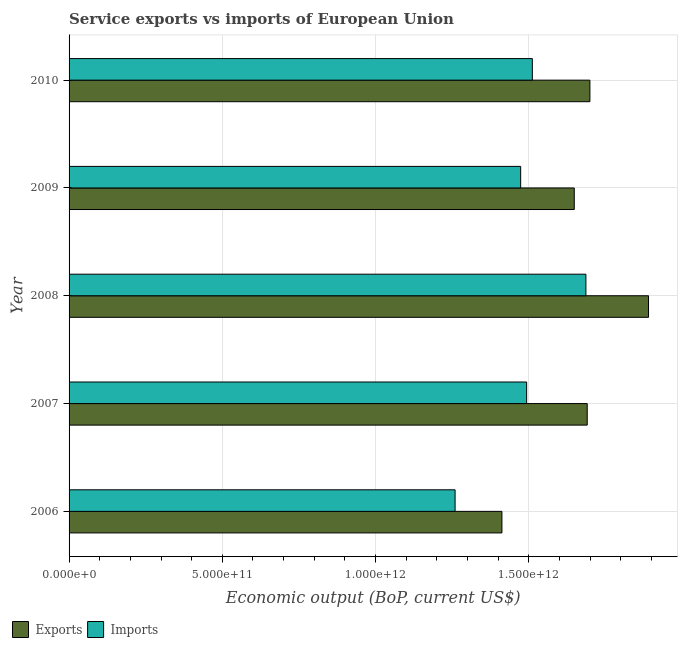How many different coloured bars are there?
Keep it short and to the point. 2. How many groups of bars are there?
Provide a succinct answer. 5. Are the number of bars per tick equal to the number of legend labels?
Your response must be concise. Yes. How many bars are there on the 3rd tick from the top?
Provide a short and direct response. 2. In how many cases, is the number of bars for a given year not equal to the number of legend labels?
Give a very brief answer. 0. What is the amount of service imports in 2008?
Your answer should be compact. 1.69e+12. Across all years, what is the maximum amount of service exports?
Offer a terse response. 1.89e+12. Across all years, what is the minimum amount of service imports?
Offer a very short reply. 1.26e+12. In which year was the amount of service imports maximum?
Make the answer very short. 2008. What is the total amount of service imports in the graph?
Ensure brevity in your answer.  7.42e+12. What is the difference between the amount of service exports in 2009 and that in 2010?
Offer a terse response. -5.11e+1. What is the difference between the amount of service imports in 2008 and the amount of service exports in 2007?
Keep it short and to the point. -4.27e+09. What is the average amount of service imports per year?
Your response must be concise. 1.48e+12. In the year 2007, what is the difference between the amount of service imports and amount of service exports?
Offer a very short reply. -1.98e+11. What is the ratio of the amount of service imports in 2007 to that in 2009?
Make the answer very short. 1.01. Is the difference between the amount of service exports in 2008 and 2009 greater than the difference between the amount of service imports in 2008 and 2009?
Offer a terse response. Yes. What is the difference between the highest and the second highest amount of service imports?
Your response must be concise. 1.75e+11. What is the difference between the highest and the lowest amount of service exports?
Offer a terse response. 4.78e+11. In how many years, is the amount of service imports greater than the average amount of service imports taken over all years?
Give a very brief answer. 3. What does the 1st bar from the top in 2010 represents?
Make the answer very short. Imports. What does the 1st bar from the bottom in 2010 represents?
Make the answer very short. Exports. What is the difference between two consecutive major ticks on the X-axis?
Your answer should be compact. 5.00e+11. Are the values on the major ticks of X-axis written in scientific E-notation?
Your answer should be very brief. Yes. Does the graph contain grids?
Offer a terse response. Yes. How many legend labels are there?
Offer a terse response. 2. How are the legend labels stacked?
Keep it short and to the point. Horizontal. What is the title of the graph?
Provide a succinct answer. Service exports vs imports of European Union. Does "Tetanus" appear as one of the legend labels in the graph?
Your answer should be very brief. No. What is the label or title of the X-axis?
Your response must be concise. Economic output (BoP, current US$). What is the Economic output (BoP, current US$) in Exports in 2006?
Offer a terse response. 1.41e+12. What is the Economic output (BoP, current US$) of Imports in 2006?
Give a very brief answer. 1.26e+12. What is the Economic output (BoP, current US$) of Exports in 2007?
Make the answer very short. 1.69e+12. What is the Economic output (BoP, current US$) of Imports in 2007?
Keep it short and to the point. 1.49e+12. What is the Economic output (BoP, current US$) in Exports in 2008?
Provide a short and direct response. 1.89e+12. What is the Economic output (BoP, current US$) in Imports in 2008?
Your answer should be very brief. 1.69e+12. What is the Economic output (BoP, current US$) of Exports in 2009?
Your response must be concise. 1.65e+12. What is the Economic output (BoP, current US$) in Imports in 2009?
Offer a very short reply. 1.47e+12. What is the Economic output (BoP, current US$) in Exports in 2010?
Provide a short and direct response. 1.70e+12. What is the Economic output (BoP, current US$) of Imports in 2010?
Provide a short and direct response. 1.51e+12. Across all years, what is the maximum Economic output (BoP, current US$) of Exports?
Provide a succinct answer. 1.89e+12. Across all years, what is the maximum Economic output (BoP, current US$) in Imports?
Ensure brevity in your answer.  1.69e+12. Across all years, what is the minimum Economic output (BoP, current US$) of Exports?
Offer a terse response. 1.41e+12. Across all years, what is the minimum Economic output (BoP, current US$) in Imports?
Provide a succinct answer. 1.26e+12. What is the total Economic output (BoP, current US$) of Exports in the graph?
Offer a very short reply. 8.34e+12. What is the total Economic output (BoP, current US$) of Imports in the graph?
Offer a very short reply. 7.42e+12. What is the difference between the Economic output (BoP, current US$) in Exports in 2006 and that in 2007?
Give a very brief answer. -2.78e+11. What is the difference between the Economic output (BoP, current US$) of Imports in 2006 and that in 2007?
Your answer should be very brief. -2.33e+11. What is the difference between the Economic output (BoP, current US$) in Exports in 2006 and that in 2008?
Ensure brevity in your answer.  -4.78e+11. What is the difference between the Economic output (BoP, current US$) in Imports in 2006 and that in 2008?
Your answer should be compact. -4.27e+11. What is the difference between the Economic output (BoP, current US$) in Exports in 2006 and that in 2009?
Offer a terse response. -2.36e+11. What is the difference between the Economic output (BoP, current US$) in Imports in 2006 and that in 2009?
Offer a very short reply. -2.14e+11. What is the difference between the Economic output (BoP, current US$) of Exports in 2006 and that in 2010?
Give a very brief answer. -2.87e+11. What is the difference between the Economic output (BoP, current US$) of Imports in 2006 and that in 2010?
Your response must be concise. -2.52e+11. What is the difference between the Economic output (BoP, current US$) in Exports in 2007 and that in 2008?
Offer a very short reply. -2.00e+11. What is the difference between the Economic output (BoP, current US$) of Imports in 2007 and that in 2008?
Offer a very short reply. -1.93e+11. What is the difference between the Economic output (BoP, current US$) of Exports in 2007 and that in 2009?
Ensure brevity in your answer.  4.23e+1. What is the difference between the Economic output (BoP, current US$) of Imports in 2007 and that in 2009?
Ensure brevity in your answer.  1.95e+1. What is the difference between the Economic output (BoP, current US$) in Exports in 2007 and that in 2010?
Provide a succinct answer. -8.79e+09. What is the difference between the Economic output (BoP, current US$) in Imports in 2007 and that in 2010?
Offer a terse response. -1.86e+1. What is the difference between the Economic output (BoP, current US$) in Exports in 2008 and that in 2009?
Offer a very short reply. 2.42e+11. What is the difference between the Economic output (BoP, current US$) of Imports in 2008 and that in 2009?
Make the answer very short. 2.13e+11. What is the difference between the Economic output (BoP, current US$) in Exports in 2008 and that in 2010?
Ensure brevity in your answer.  1.91e+11. What is the difference between the Economic output (BoP, current US$) of Imports in 2008 and that in 2010?
Offer a very short reply. 1.75e+11. What is the difference between the Economic output (BoP, current US$) in Exports in 2009 and that in 2010?
Provide a short and direct response. -5.11e+1. What is the difference between the Economic output (BoP, current US$) of Imports in 2009 and that in 2010?
Your response must be concise. -3.81e+1. What is the difference between the Economic output (BoP, current US$) of Exports in 2006 and the Economic output (BoP, current US$) of Imports in 2007?
Your answer should be very brief. -8.06e+1. What is the difference between the Economic output (BoP, current US$) of Exports in 2006 and the Economic output (BoP, current US$) of Imports in 2008?
Make the answer very short. -2.74e+11. What is the difference between the Economic output (BoP, current US$) in Exports in 2006 and the Economic output (BoP, current US$) in Imports in 2009?
Ensure brevity in your answer.  -6.11e+1. What is the difference between the Economic output (BoP, current US$) in Exports in 2006 and the Economic output (BoP, current US$) in Imports in 2010?
Offer a very short reply. -9.92e+1. What is the difference between the Economic output (BoP, current US$) in Exports in 2007 and the Economic output (BoP, current US$) in Imports in 2008?
Give a very brief answer. 4.27e+09. What is the difference between the Economic output (BoP, current US$) in Exports in 2007 and the Economic output (BoP, current US$) in Imports in 2009?
Ensure brevity in your answer.  2.17e+11. What is the difference between the Economic output (BoP, current US$) of Exports in 2007 and the Economic output (BoP, current US$) of Imports in 2010?
Offer a terse response. 1.79e+11. What is the difference between the Economic output (BoP, current US$) in Exports in 2008 and the Economic output (BoP, current US$) in Imports in 2009?
Make the answer very short. 4.17e+11. What is the difference between the Economic output (BoP, current US$) in Exports in 2008 and the Economic output (BoP, current US$) in Imports in 2010?
Keep it short and to the point. 3.79e+11. What is the difference between the Economic output (BoP, current US$) of Exports in 2009 and the Economic output (BoP, current US$) of Imports in 2010?
Give a very brief answer. 1.37e+11. What is the average Economic output (BoP, current US$) in Exports per year?
Offer a terse response. 1.67e+12. What is the average Economic output (BoP, current US$) in Imports per year?
Provide a short and direct response. 1.48e+12. In the year 2006, what is the difference between the Economic output (BoP, current US$) of Exports and Economic output (BoP, current US$) of Imports?
Make the answer very short. 1.53e+11. In the year 2007, what is the difference between the Economic output (BoP, current US$) in Exports and Economic output (BoP, current US$) in Imports?
Keep it short and to the point. 1.98e+11. In the year 2008, what is the difference between the Economic output (BoP, current US$) in Exports and Economic output (BoP, current US$) in Imports?
Keep it short and to the point. 2.04e+11. In the year 2009, what is the difference between the Economic output (BoP, current US$) of Exports and Economic output (BoP, current US$) of Imports?
Ensure brevity in your answer.  1.75e+11. In the year 2010, what is the difference between the Economic output (BoP, current US$) in Exports and Economic output (BoP, current US$) in Imports?
Make the answer very short. 1.88e+11. What is the ratio of the Economic output (BoP, current US$) in Exports in 2006 to that in 2007?
Offer a very short reply. 0.84. What is the ratio of the Economic output (BoP, current US$) in Imports in 2006 to that in 2007?
Offer a terse response. 0.84. What is the ratio of the Economic output (BoP, current US$) of Exports in 2006 to that in 2008?
Your response must be concise. 0.75. What is the ratio of the Economic output (BoP, current US$) of Imports in 2006 to that in 2008?
Ensure brevity in your answer.  0.75. What is the ratio of the Economic output (BoP, current US$) in Exports in 2006 to that in 2009?
Give a very brief answer. 0.86. What is the ratio of the Economic output (BoP, current US$) of Imports in 2006 to that in 2009?
Offer a terse response. 0.85. What is the ratio of the Economic output (BoP, current US$) of Exports in 2006 to that in 2010?
Make the answer very short. 0.83. What is the ratio of the Economic output (BoP, current US$) of Imports in 2006 to that in 2010?
Provide a short and direct response. 0.83. What is the ratio of the Economic output (BoP, current US$) of Exports in 2007 to that in 2008?
Offer a very short reply. 0.89. What is the ratio of the Economic output (BoP, current US$) of Imports in 2007 to that in 2008?
Make the answer very short. 0.89. What is the ratio of the Economic output (BoP, current US$) in Exports in 2007 to that in 2009?
Ensure brevity in your answer.  1.03. What is the ratio of the Economic output (BoP, current US$) in Imports in 2007 to that in 2009?
Your answer should be compact. 1.01. What is the ratio of the Economic output (BoP, current US$) of Exports in 2008 to that in 2009?
Provide a succinct answer. 1.15. What is the ratio of the Economic output (BoP, current US$) of Imports in 2008 to that in 2009?
Keep it short and to the point. 1.14. What is the ratio of the Economic output (BoP, current US$) of Exports in 2008 to that in 2010?
Make the answer very short. 1.11. What is the ratio of the Economic output (BoP, current US$) of Imports in 2008 to that in 2010?
Give a very brief answer. 1.12. What is the ratio of the Economic output (BoP, current US$) in Exports in 2009 to that in 2010?
Give a very brief answer. 0.97. What is the ratio of the Economic output (BoP, current US$) in Imports in 2009 to that in 2010?
Your answer should be very brief. 0.97. What is the difference between the highest and the second highest Economic output (BoP, current US$) in Exports?
Give a very brief answer. 1.91e+11. What is the difference between the highest and the second highest Economic output (BoP, current US$) of Imports?
Provide a short and direct response. 1.75e+11. What is the difference between the highest and the lowest Economic output (BoP, current US$) in Exports?
Make the answer very short. 4.78e+11. What is the difference between the highest and the lowest Economic output (BoP, current US$) of Imports?
Provide a short and direct response. 4.27e+11. 